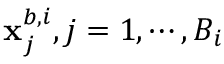<formula> <loc_0><loc_0><loc_500><loc_500>x _ { j } ^ { b , i } , j = 1 , \cdots , B _ { i }</formula> 